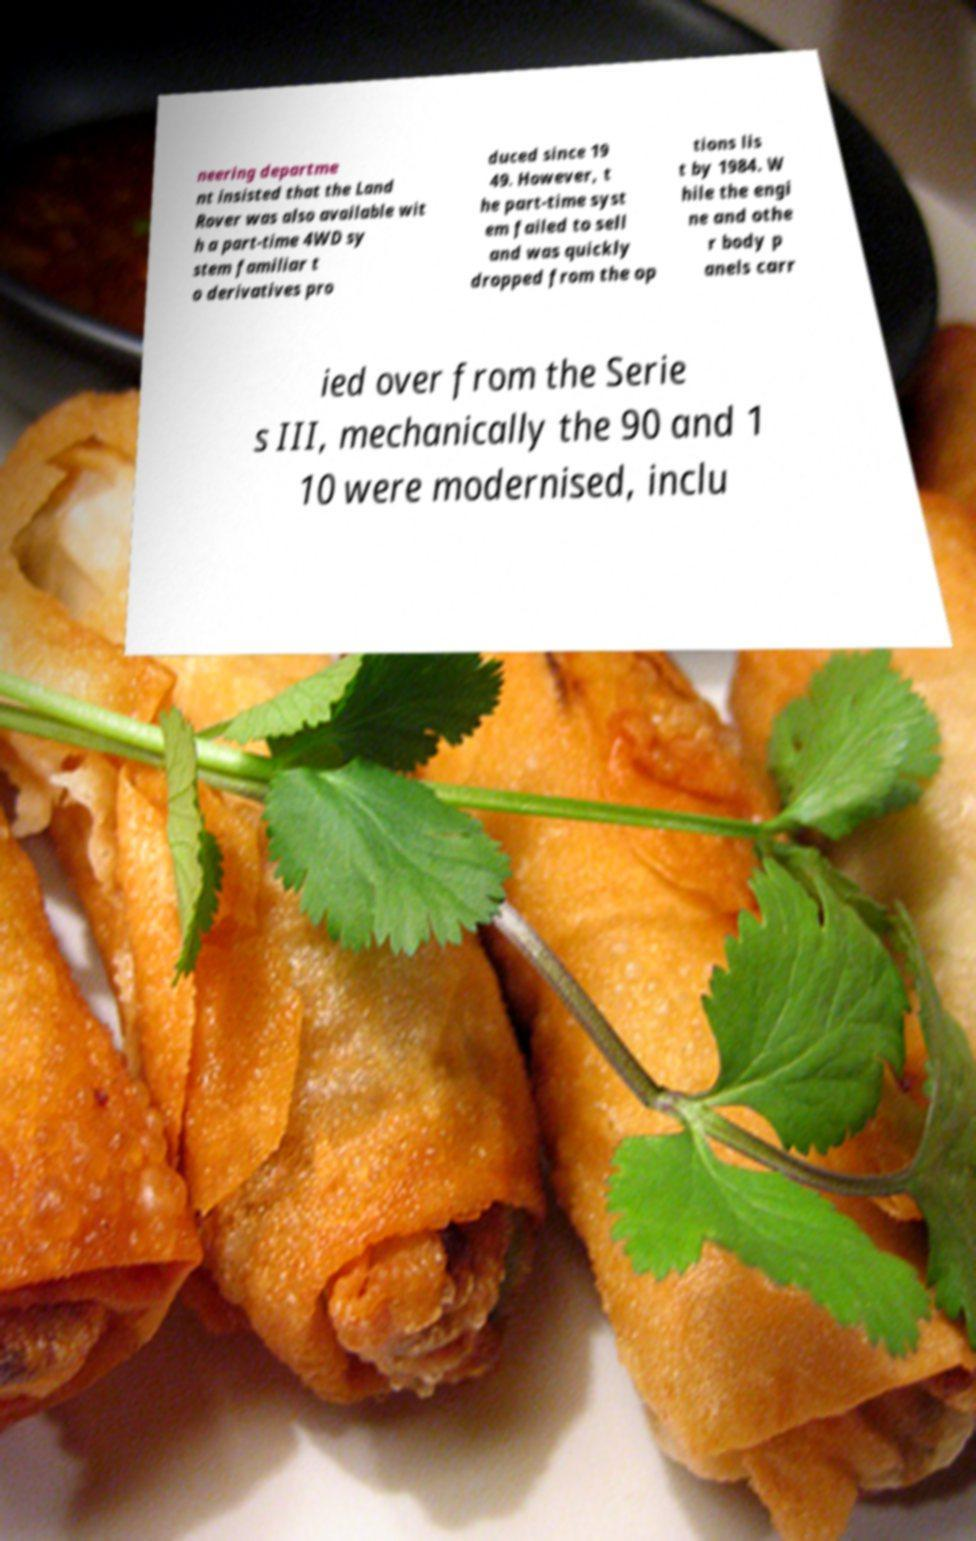For documentation purposes, I need the text within this image transcribed. Could you provide that? neering departme nt insisted that the Land Rover was also available wit h a part-time 4WD sy stem familiar t o derivatives pro duced since 19 49. However, t he part-time syst em failed to sell and was quickly dropped from the op tions lis t by 1984. W hile the engi ne and othe r body p anels carr ied over from the Serie s III, mechanically the 90 and 1 10 were modernised, inclu 